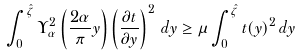Convert formula to latex. <formula><loc_0><loc_0><loc_500><loc_500>\int _ { 0 } ^ { \hat { \zeta } } \Upsilon _ { \alpha } ^ { 2 } \left ( \frac { 2 \alpha } { \pi } y \right ) \left ( \frac { \partial t } { \partial y } \right ) ^ { 2 } \, d y \geq \mu \int _ { 0 } ^ { \hat { \zeta } } t ( y ) ^ { 2 } \, d y</formula> 